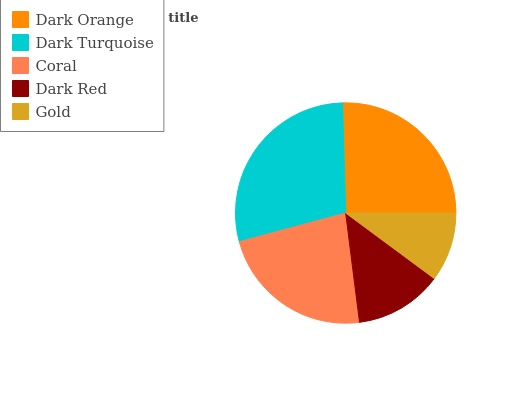Is Gold the minimum?
Answer yes or no. Yes. Is Dark Turquoise the maximum?
Answer yes or no. Yes. Is Coral the minimum?
Answer yes or no. No. Is Coral the maximum?
Answer yes or no. No. Is Dark Turquoise greater than Coral?
Answer yes or no. Yes. Is Coral less than Dark Turquoise?
Answer yes or no. Yes. Is Coral greater than Dark Turquoise?
Answer yes or no. No. Is Dark Turquoise less than Coral?
Answer yes or no. No. Is Coral the high median?
Answer yes or no. Yes. Is Coral the low median?
Answer yes or no. Yes. Is Dark Red the high median?
Answer yes or no. No. Is Dark Orange the low median?
Answer yes or no. No. 